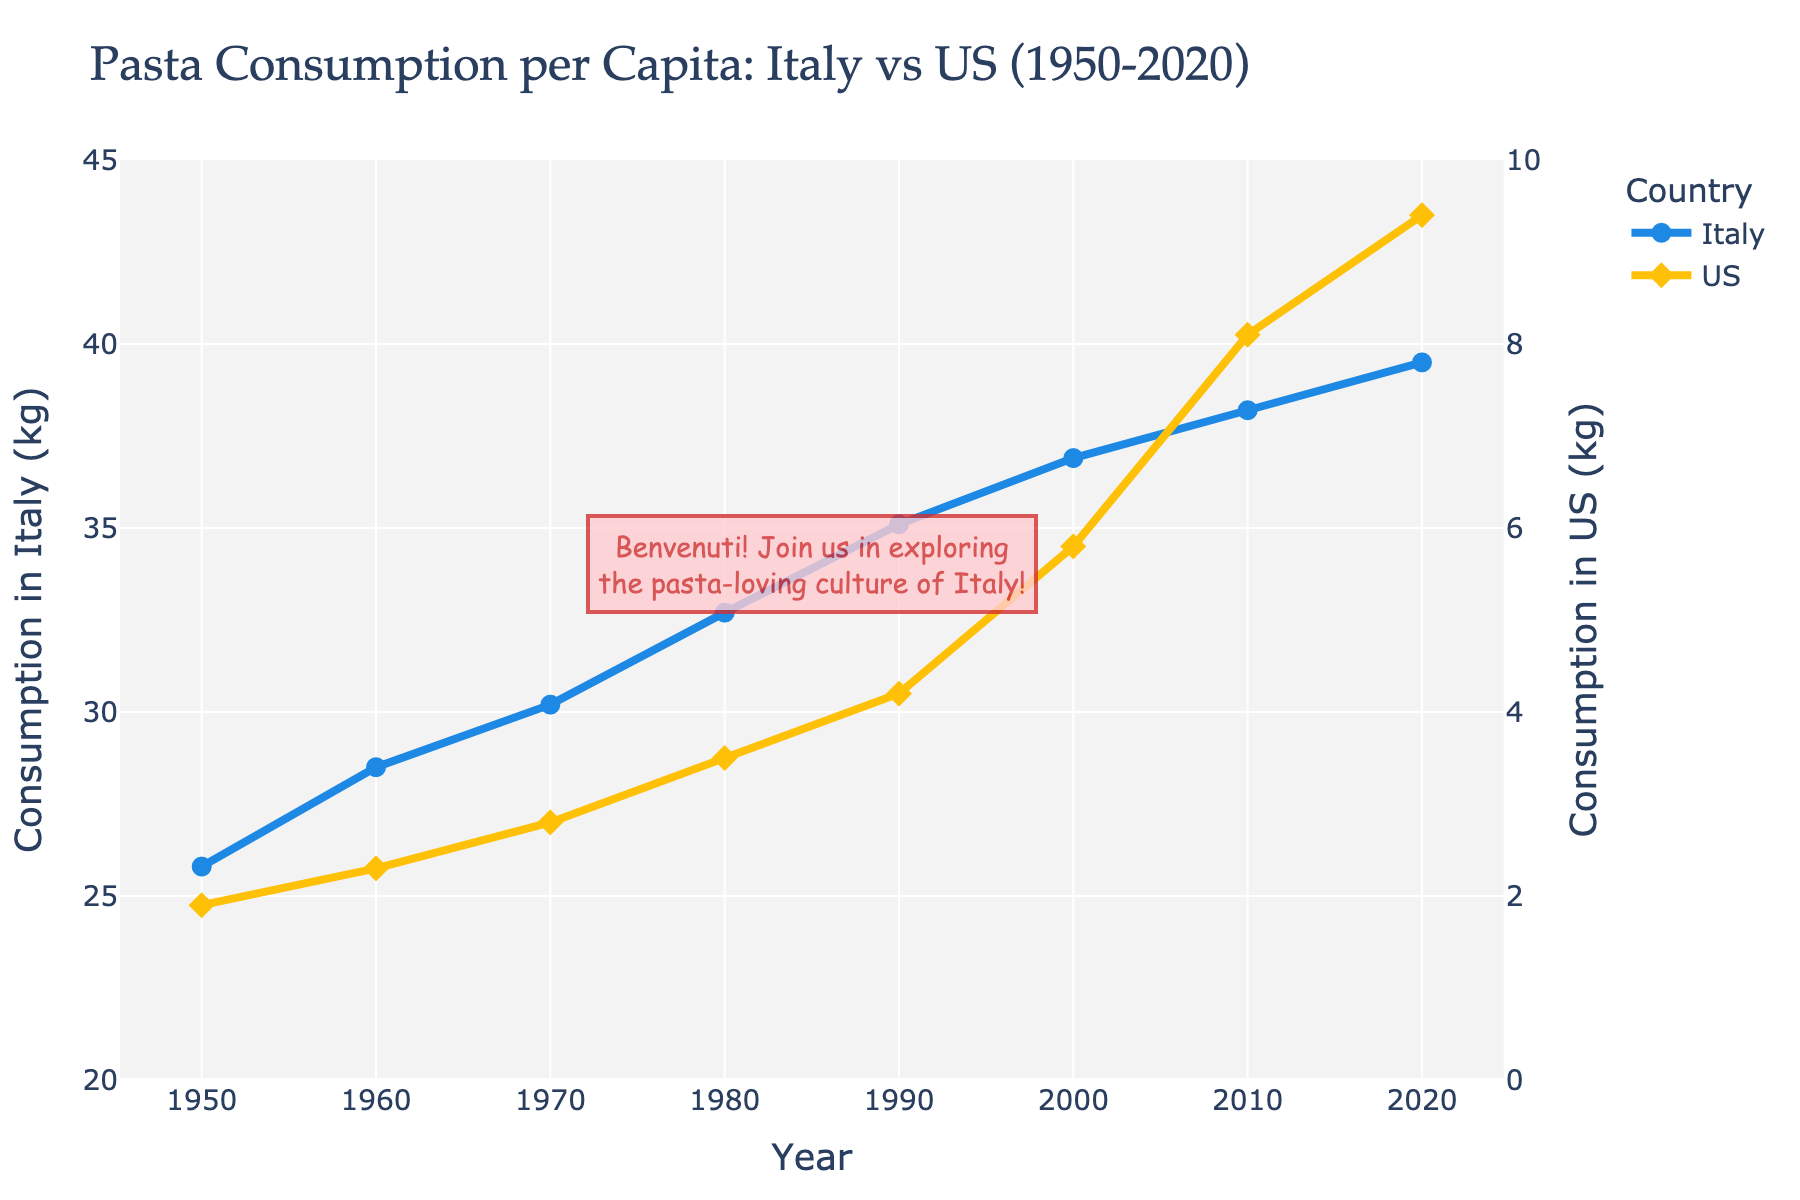What year did pasta consumption in Italy reach a value of 39.5 kg per capita? Locate the point where the Italy line reaches 39.5 kg per capita by following the vertical position and matching it with the corresponding year on the x-axis.
Answer: 2020 During which decade did the US see the highest growth in pasta consumption per capita? The highest growth can be identified by looking for the steepest increase in the US line. Calculate the differences in consumption for each decade and compare them. From 2000 to 2010, consumption increased from 5.8 kg to 8.1 kg, a growth of 2.3 kg. This is the highest growth.
Answer: 2000-2010 How many kilograms did pasta consumption per capita in the US increase from 1950 to 2020? Subtract the value of pasta consumption in the US in 1950 from the value in 2020. The consumption increased from 1.9 kg in 1950 to 9.4 kg in 2020. Subtracting these gives 9.4 - 1.9 = 7.5 kg.
Answer: 7.5 kg What is the range of pasta consumption per capita in Italy from 1950 to 2020? Identify the highest and lowest values for Italy on the y-axis and calculate the range by subtracting the lowest value from the highest value. The highest value is 39.5 kg (2020) and the lowest is 25.8 kg (1950). Therefore, the range is 39.5 - 25.8 = 13.7 kg.
Answer: 13.7 kg Which country had the higher pasta consumption per capita in 1980, and by how much? Compare the values for Italy and the US in 1980 by looking at their respective heights on the y-axis. Italy's consumption was 32.7 kg and the US's consumption was 3.5 kg. Subtract the US's value from Italy's value to find the difference: 32.7 - 3.5 = 29.2 kg.
Answer: Italy by 29.2 kg What is the approximate average pasta consumption per capita in Italy from 1950 to 2020? Calculate the average by summing all the values for Italy and dividing by the number of years. (25.8 + 28.5 + 30.2 + 32.7 + 35.1 + 36.9 + 38.2 + 39.5) / 8 = 33.61 kg.
Answer: 33.61 kg At what rate did pasta consumption per capita in Italy change per decade between 1950 and 2020? Calculate the difference in consumption for each decade and find the average rate of change by dividing these differences by the number of years per decade (10). [(28.5-25.8)+(30.2-28.5)+(32.7-30.2)+(35.1-32.7)+(36.9-35.1)+(38.2-36.9)+(39.5-38.2)] / 7 = (2.7+1.7+2.5+2.4+1.8+1.3+1.3) / 7 = 1.9643 kg/decade.
Answer: 1.96 kg/decade 